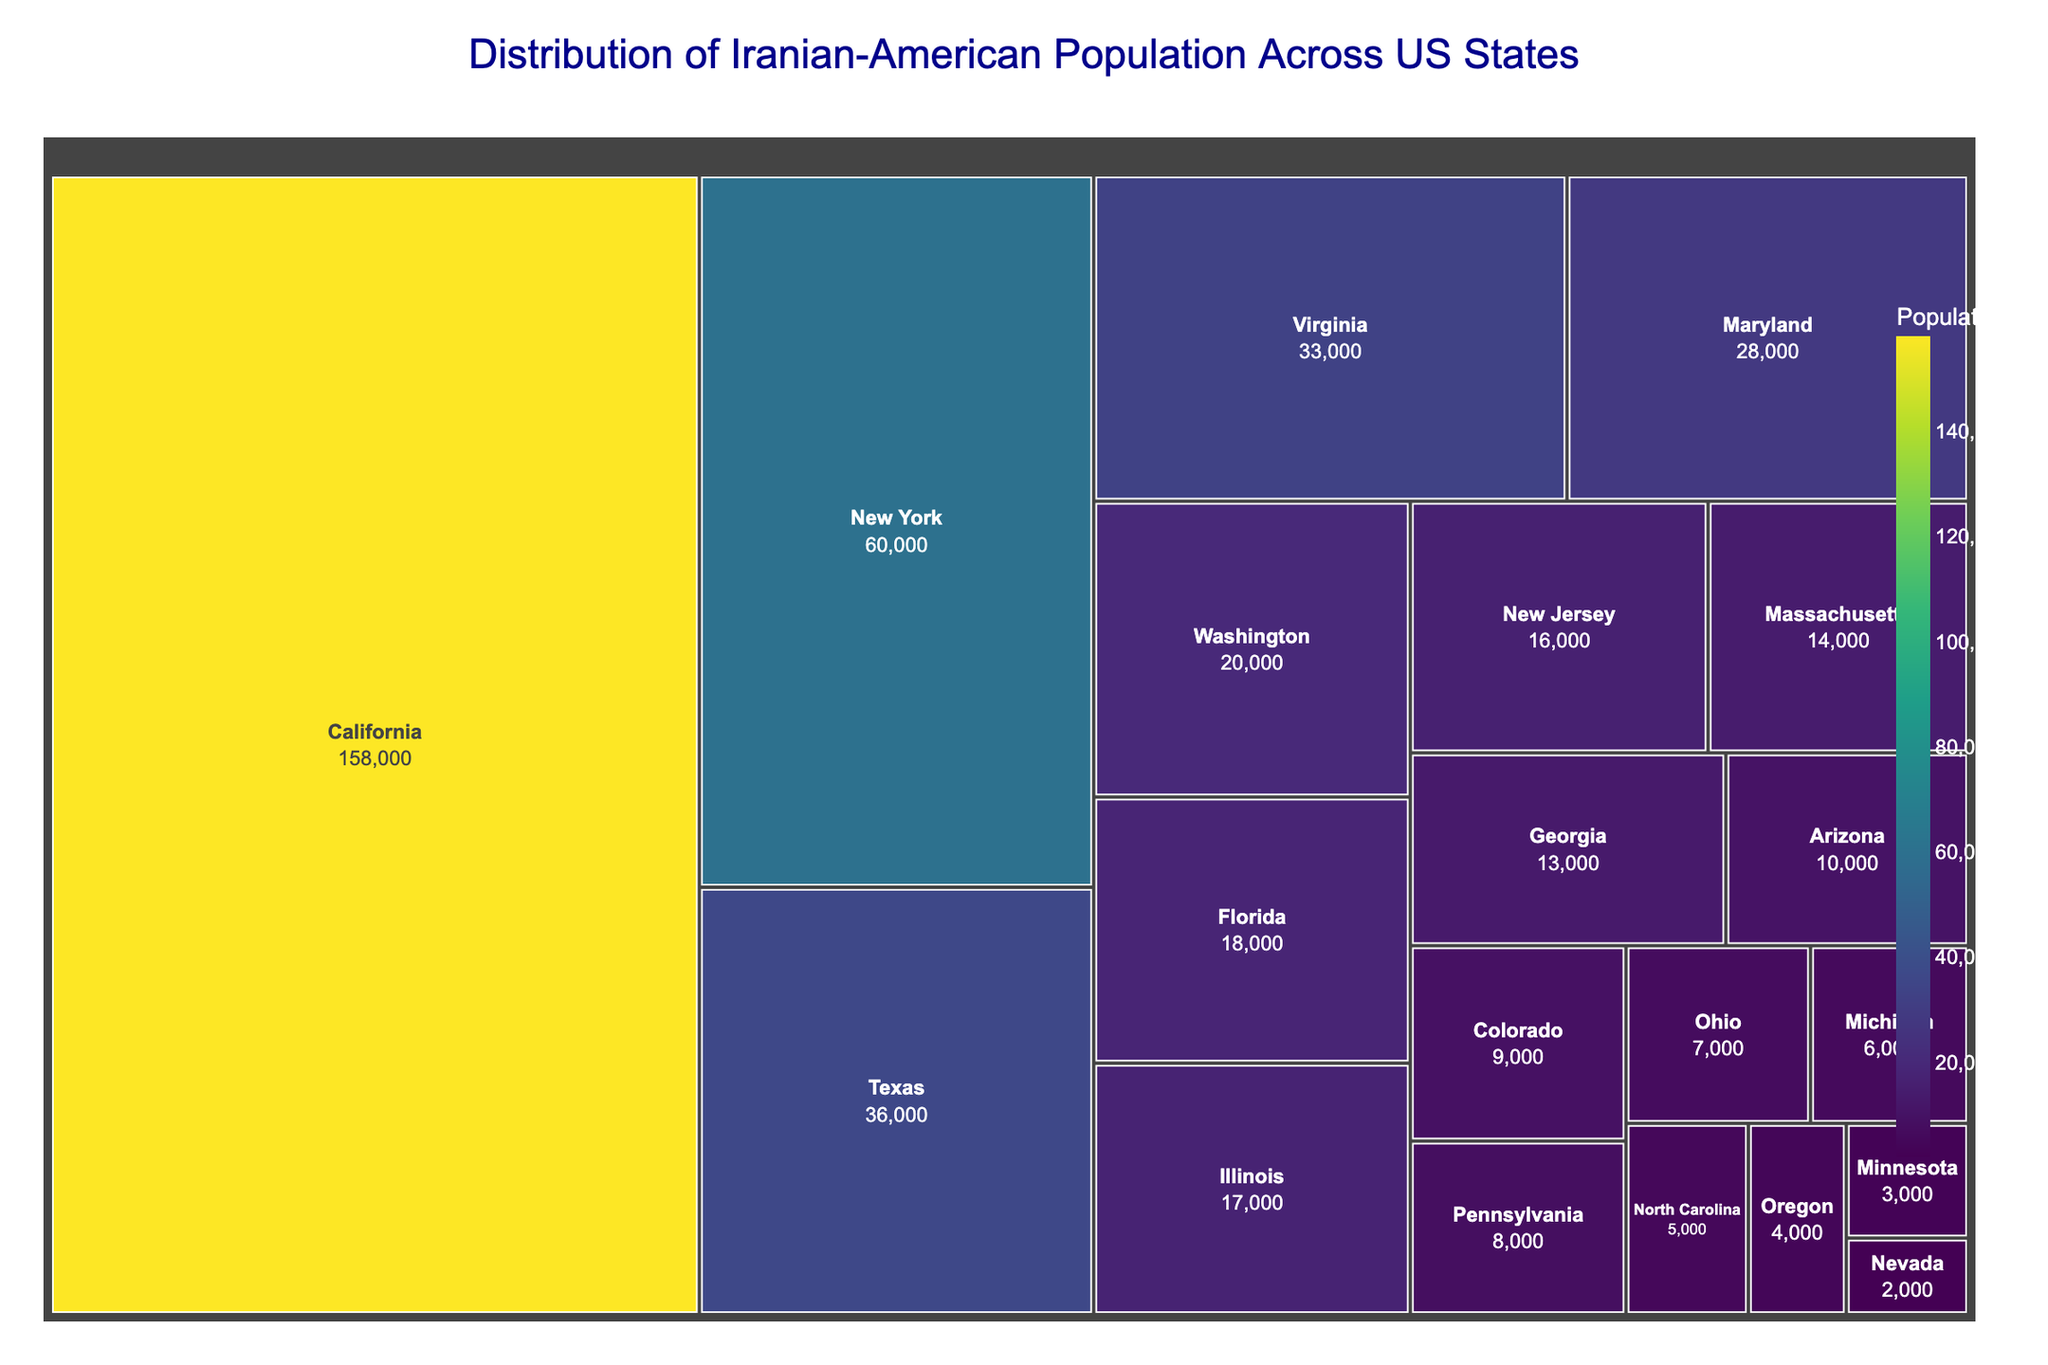What is the title of the treemap? The title is displayed at the top of the figure.
Answer: Distribution of Iranian-American Population Across US States Which state has the highest Iranian-American population? The state with the largest area in the treemap represents the highest population.
Answer: California How many states have a population of Iranian-Americans greater than 20,000? Count the states with areas larger than the blocks representing populations equal to 20,000.
Answer: 5 What is the combined population of Iranian-Americans in New York and Texas? Look at the populations of New York (60,000) and Texas (36,000). Add these numbers together: 60,000 + 36,000
Answer: 96,000 How does the population of Iranian-Americans in California compare with that in Florida? Compare the area of the California block to the Florida block and note the numbers provided for each. California has 158,000 and Florida has 18,000.
Answer: California has a significantly larger population than Florida Which state has the smallest population of Iranian-Americans and what is that population? Find the smallest block and check its label, which is Nevada with 2,000.
Answer: Nevada, 2,000 What is the average population of Iranian-Americans across the top five states? Take the populations of the top five states (California, New York, Texas, Virginia, Maryland), add them together and divide by 5. (158,000 + 60,000 + 36,000 + 33,000 + 28,000) / 5
Answer: 63,000 What is the color gradient representing in the treemap? The color gradient scales with the population size, with different shades indicating different levels of population density.
Answer: Population size How much more populous is the Iranian-American community in California compared to the combined population of Maryland and Virginia? Add the populations of Maryland (28,000) and Virginia (33,000) and subtract this sum from California's population: 158,000 - (28,000 + 33,000)
Answer: 97,000 How many states have a population of Iranian-Americans less than 10,000? Identify and count the number of states with populations less than 10,000 in the treemap. There are 8 states: Colorado, Pennsylvania, Ohio, Michigan, North Carolina, Oregon, Minnesota, Nevada.
Answer: 8 